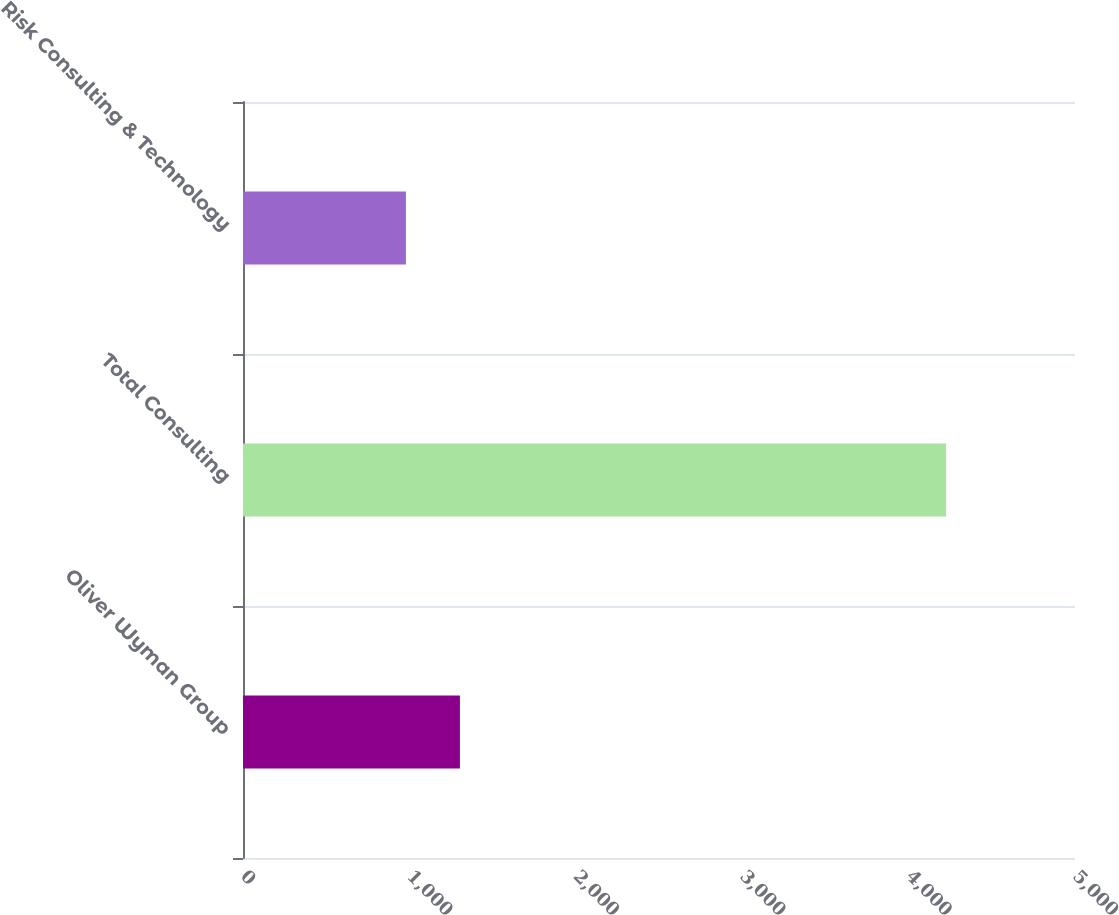<chart> <loc_0><loc_0><loc_500><loc_500><bar_chart><fcel>Oliver Wyman Group<fcel>Total Consulting<fcel>Risk Consulting & Technology<nl><fcel>1303.6<fcel>4225<fcel>979<nl></chart> 